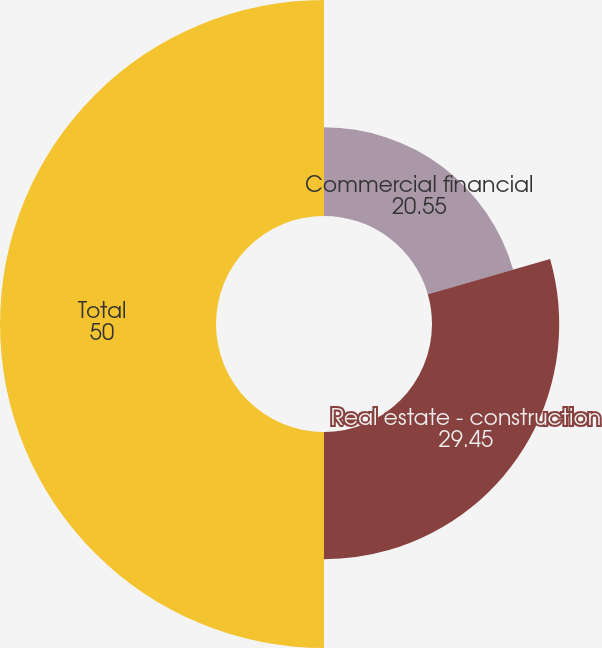<chart> <loc_0><loc_0><loc_500><loc_500><pie_chart><fcel>Commercial financial<fcel>Real estate - construction<fcel>Total<nl><fcel>20.55%<fcel>29.45%<fcel>50.0%<nl></chart> 